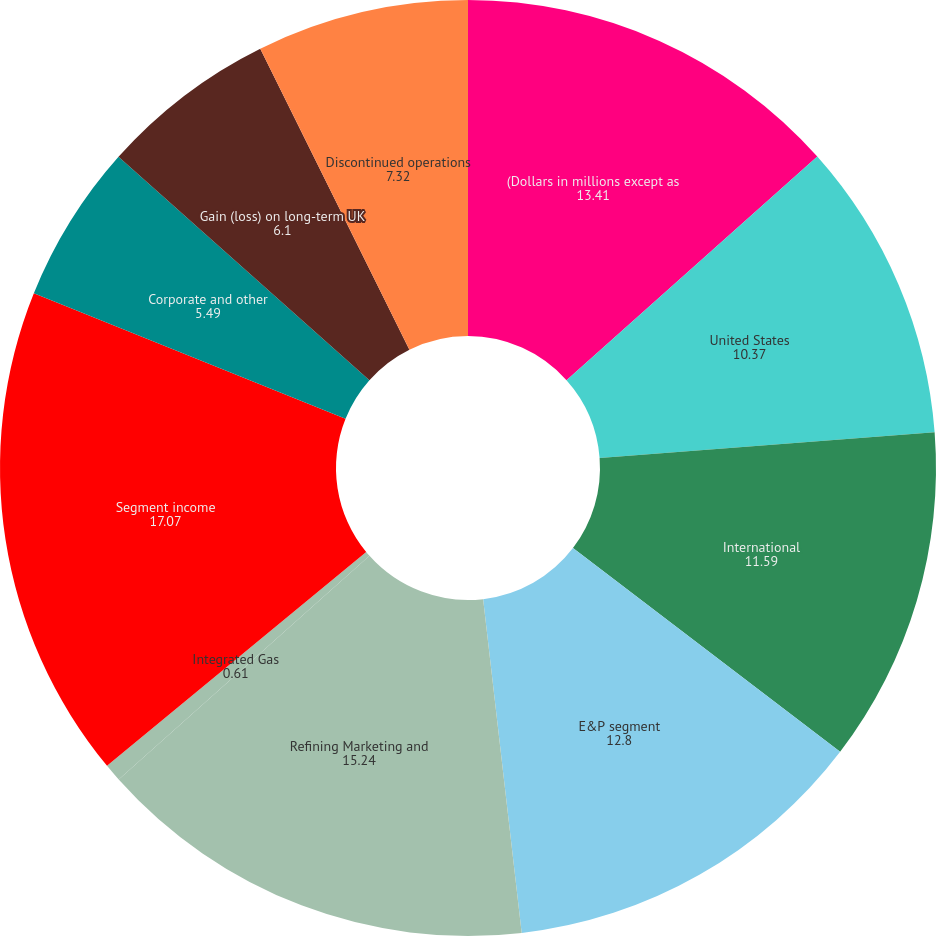Convert chart. <chart><loc_0><loc_0><loc_500><loc_500><pie_chart><fcel>(Dollars in millions except as<fcel>United States<fcel>International<fcel>E&P segment<fcel>Refining Marketing and<fcel>Integrated Gas<fcel>Segment income<fcel>Corporate and other<fcel>Gain (loss) on long-term UK<fcel>Discontinued operations<nl><fcel>13.41%<fcel>10.37%<fcel>11.59%<fcel>12.8%<fcel>15.24%<fcel>0.61%<fcel>17.07%<fcel>5.49%<fcel>6.1%<fcel>7.32%<nl></chart> 